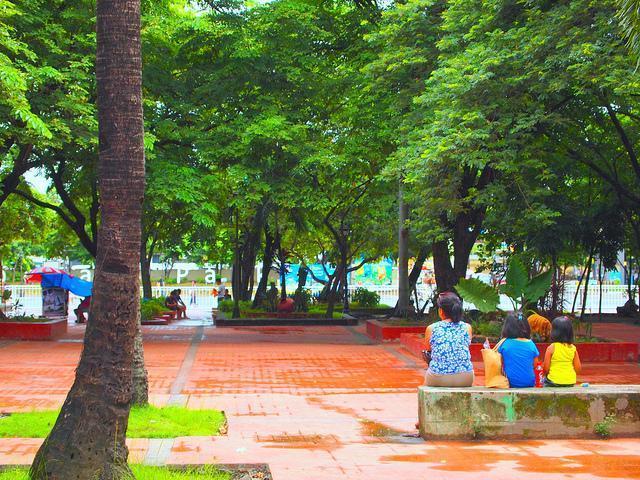How many people can be seen?
Give a very brief answer. 2. 